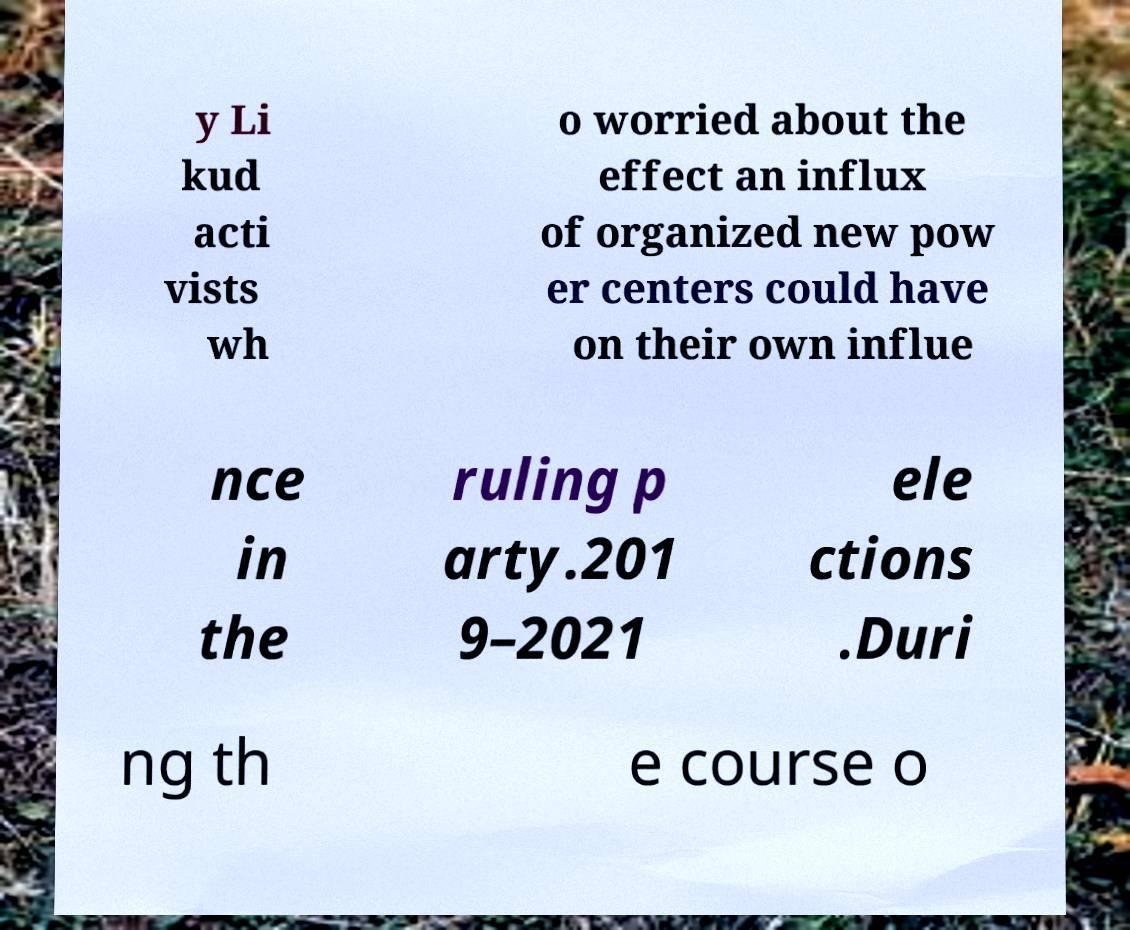Could you extract and type out the text from this image? y Li kud acti vists wh o worried about the effect an influx of organized new pow er centers could have on their own influe nce in the ruling p arty.201 9–2021 ele ctions .Duri ng th e course o 